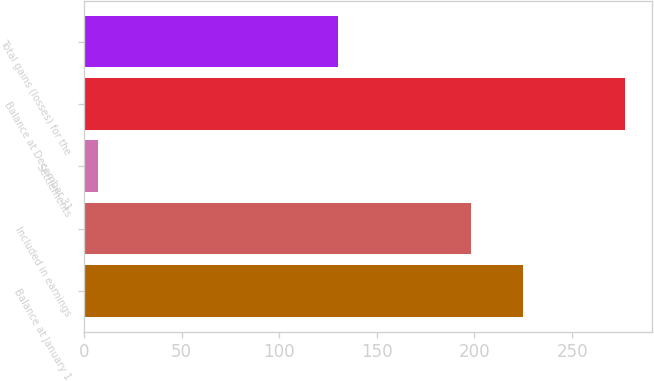Convert chart to OTSL. <chart><loc_0><loc_0><loc_500><loc_500><bar_chart><fcel>Balance at January 1<fcel>Included in earnings<fcel>Settlements<fcel>Balance at December 31<fcel>Total gains (losses) for the<nl><fcel>225<fcel>198<fcel>7<fcel>277<fcel>130<nl></chart> 